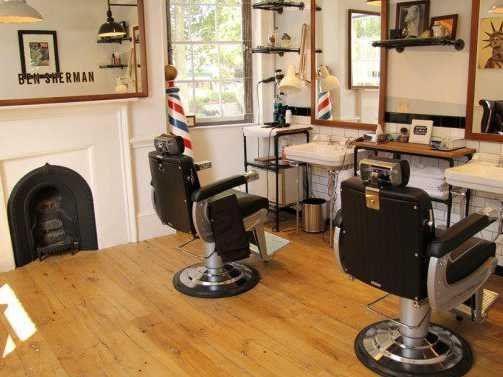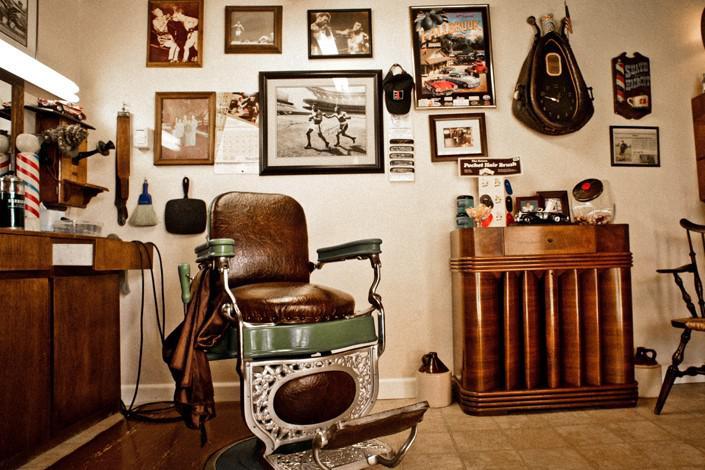The first image is the image on the left, the second image is the image on the right. Evaluate the accuracy of this statement regarding the images: "There is a total of three people in the barber shop.". Is it true? Answer yes or no. No. The first image is the image on the left, the second image is the image on the right. Given the left and right images, does the statement "There are people in both images." hold true? Answer yes or no. No. 